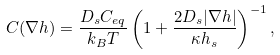Convert formula to latex. <formula><loc_0><loc_0><loc_500><loc_500>C ( \nabla h ) = \frac { D _ { s } C _ { e q } } { k _ { B } T } \left ( 1 + \frac { 2 D _ { s } | \nabla h | } { \kappa h _ { s } } \right ) ^ { - 1 } ,</formula> 